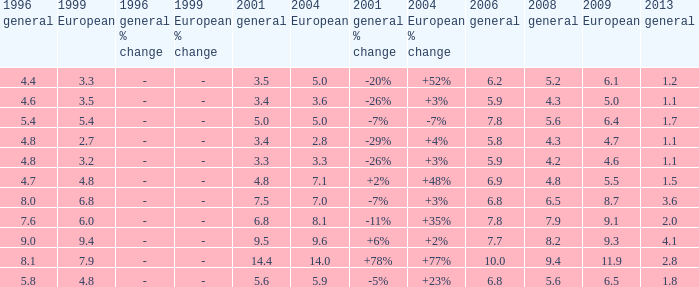What was the value for 2004 European with less than 7.5 in general 2001, less than 6.4 in 2009 European, and less than 1.5 in general 2013 with 4.3 in 2008 general? 3.6, 2.8. 